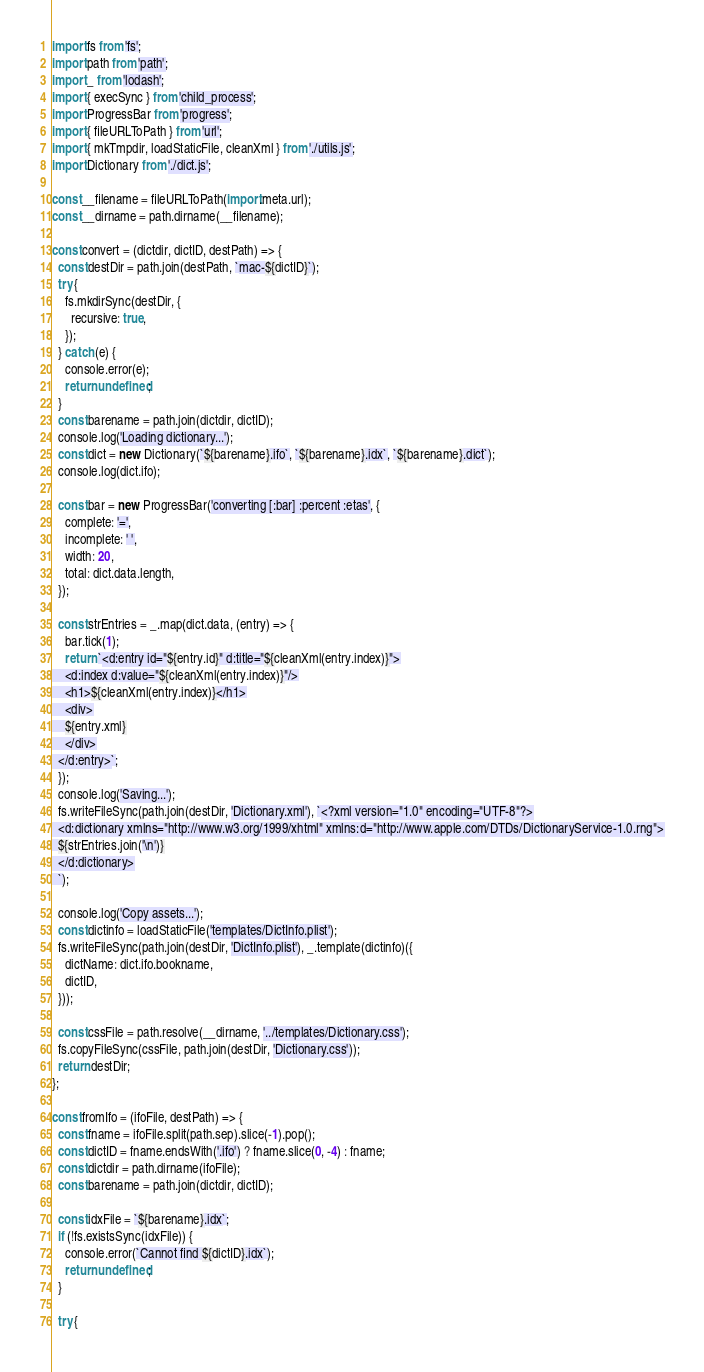Convert code to text. <code><loc_0><loc_0><loc_500><loc_500><_JavaScript_>import fs from 'fs';
import path from 'path';
import _ from 'lodash';
import { execSync } from 'child_process';
import ProgressBar from 'progress';
import { fileURLToPath } from 'url';
import { mkTmpdir, loadStaticFile, cleanXml } from './utils.js';
import Dictionary from './dict.js';

const __filename = fileURLToPath(import.meta.url);
const __dirname = path.dirname(__filename);

const convert = (dictdir, dictID, destPath) => {
  const destDir = path.join(destPath, `mac-${dictID}`);
  try {
    fs.mkdirSync(destDir, {
      recursive: true,
    });
  } catch (e) {
    console.error(e);
    return undefined;
  }
  const barename = path.join(dictdir, dictID);
  console.log('Loading dictionary...');
  const dict = new Dictionary(`${barename}.ifo`, `${barename}.idx`, `${barename}.dict`);
  console.log(dict.ifo);

  const bar = new ProgressBar('converting [:bar] :percent :etas', {
    complete: '=',
    incomplete: ' ',
    width: 20,
    total: dict.data.length,
  });

  const strEntries = _.map(dict.data, (entry) => {
    bar.tick(1);
    return `<d:entry id="${entry.id}" d:title="${cleanXml(entry.index)}">
    <d:index d:value="${cleanXml(entry.index)}"/>
    <h1>${cleanXml(entry.index)}</h1>
    <div>
    ${entry.xml}
    </div>
  </d:entry>`;
  });
  console.log('Saving...');
  fs.writeFileSync(path.join(destDir, 'Dictionary.xml'), `<?xml version="1.0" encoding="UTF-8"?>
  <d:dictionary xmlns="http://www.w3.org/1999/xhtml" xmlns:d="http://www.apple.com/DTDs/DictionaryService-1.0.rng">
  ${strEntries.join('\n')}
  </d:dictionary>
  `);

  console.log('Copy assets...');
  const dictinfo = loadStaticFile('templates/DictInfo.plist');
  fs.writeFileSync(path.join(destDir, 'DictInfo.plist'), _.template(dictinfo)({
    dictName: dict.ifo.bookname,
    dictID,
  }));

  const cssFile = path.resolve(__dirname, '../templates/Dictionary.css');
  fs.copyFileSync(cssFile, path.join(destDir, 'Dictionary.css'));
  return destDir;
};

const fromIfo = (ifoFile, destPath) => {
  const fname = ifoFile.split(path.sep).slice(-1).pop();
  const dictID = fname.endsWith('.ifo') ? fname.slice(0, -4) : fname;
  const dictdir = path.dirname(ifoFile);
  const barename = path.join(dictdir, dictID);

  const idxFile = `${barename}.idx`;
  if (!fs.existsSync(idxFile)) {
    console.error(`Cannot find ${dictID}.idx`);
    return undefined;
  }

  try {</code> 